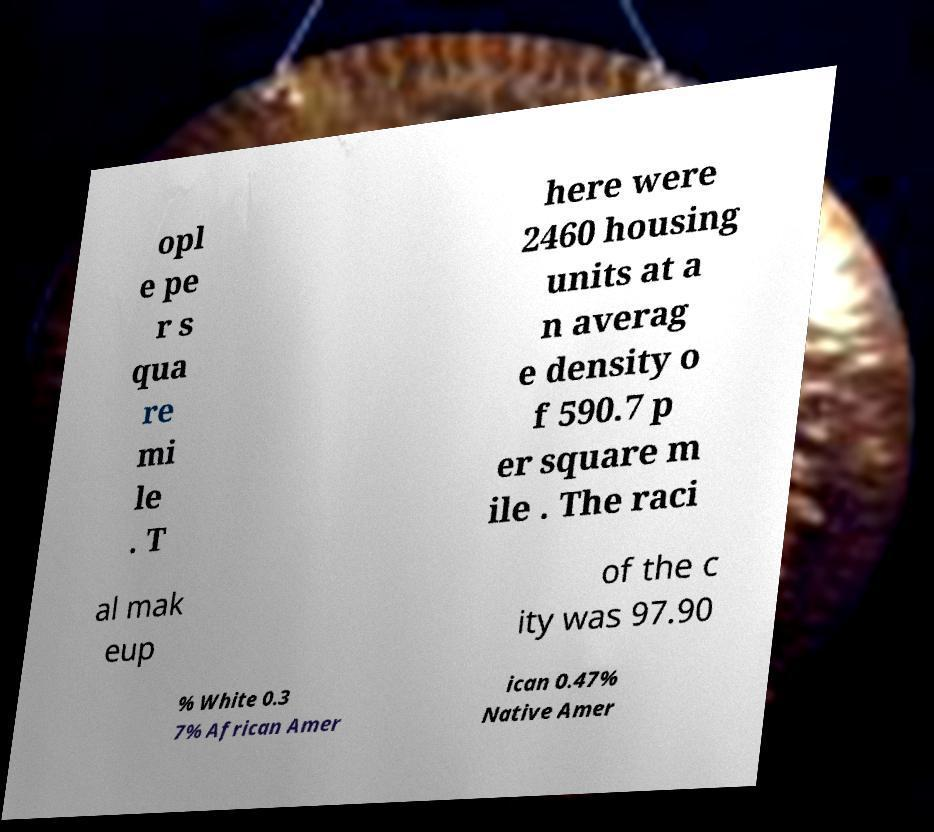Can you read and provide the text displayed in the image?This photo seems to have some interesting text. Can you extract and type it out for me? opl e pe r s qua re mi le . T here were 2460 housing units at a n averag e density o f 590.7 p er square m ile . The raci al mak eup of the c ity was 97.90 % White 0.3 7% African Amer ican 0.47% Native Amer 